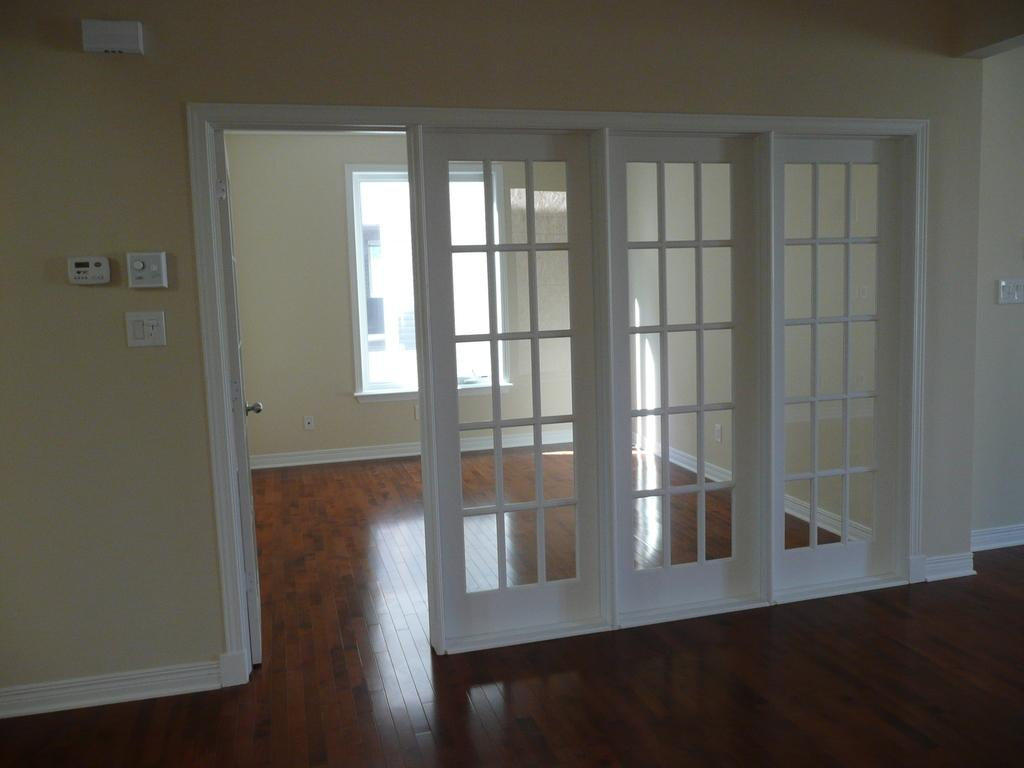What electrical device is present in the image? There is a switch board in the image. What is another feature of the room that can be seen in the image? There is a door in the image. What allows natural light to enter the room in the image? There are windows in the image. What surface is visible in the image? There is a floor visible in the image. What type of haircut is the face on the side of the image getting? There is no face or haircut present in the image; it features a switch board, door, windows, and floor. 